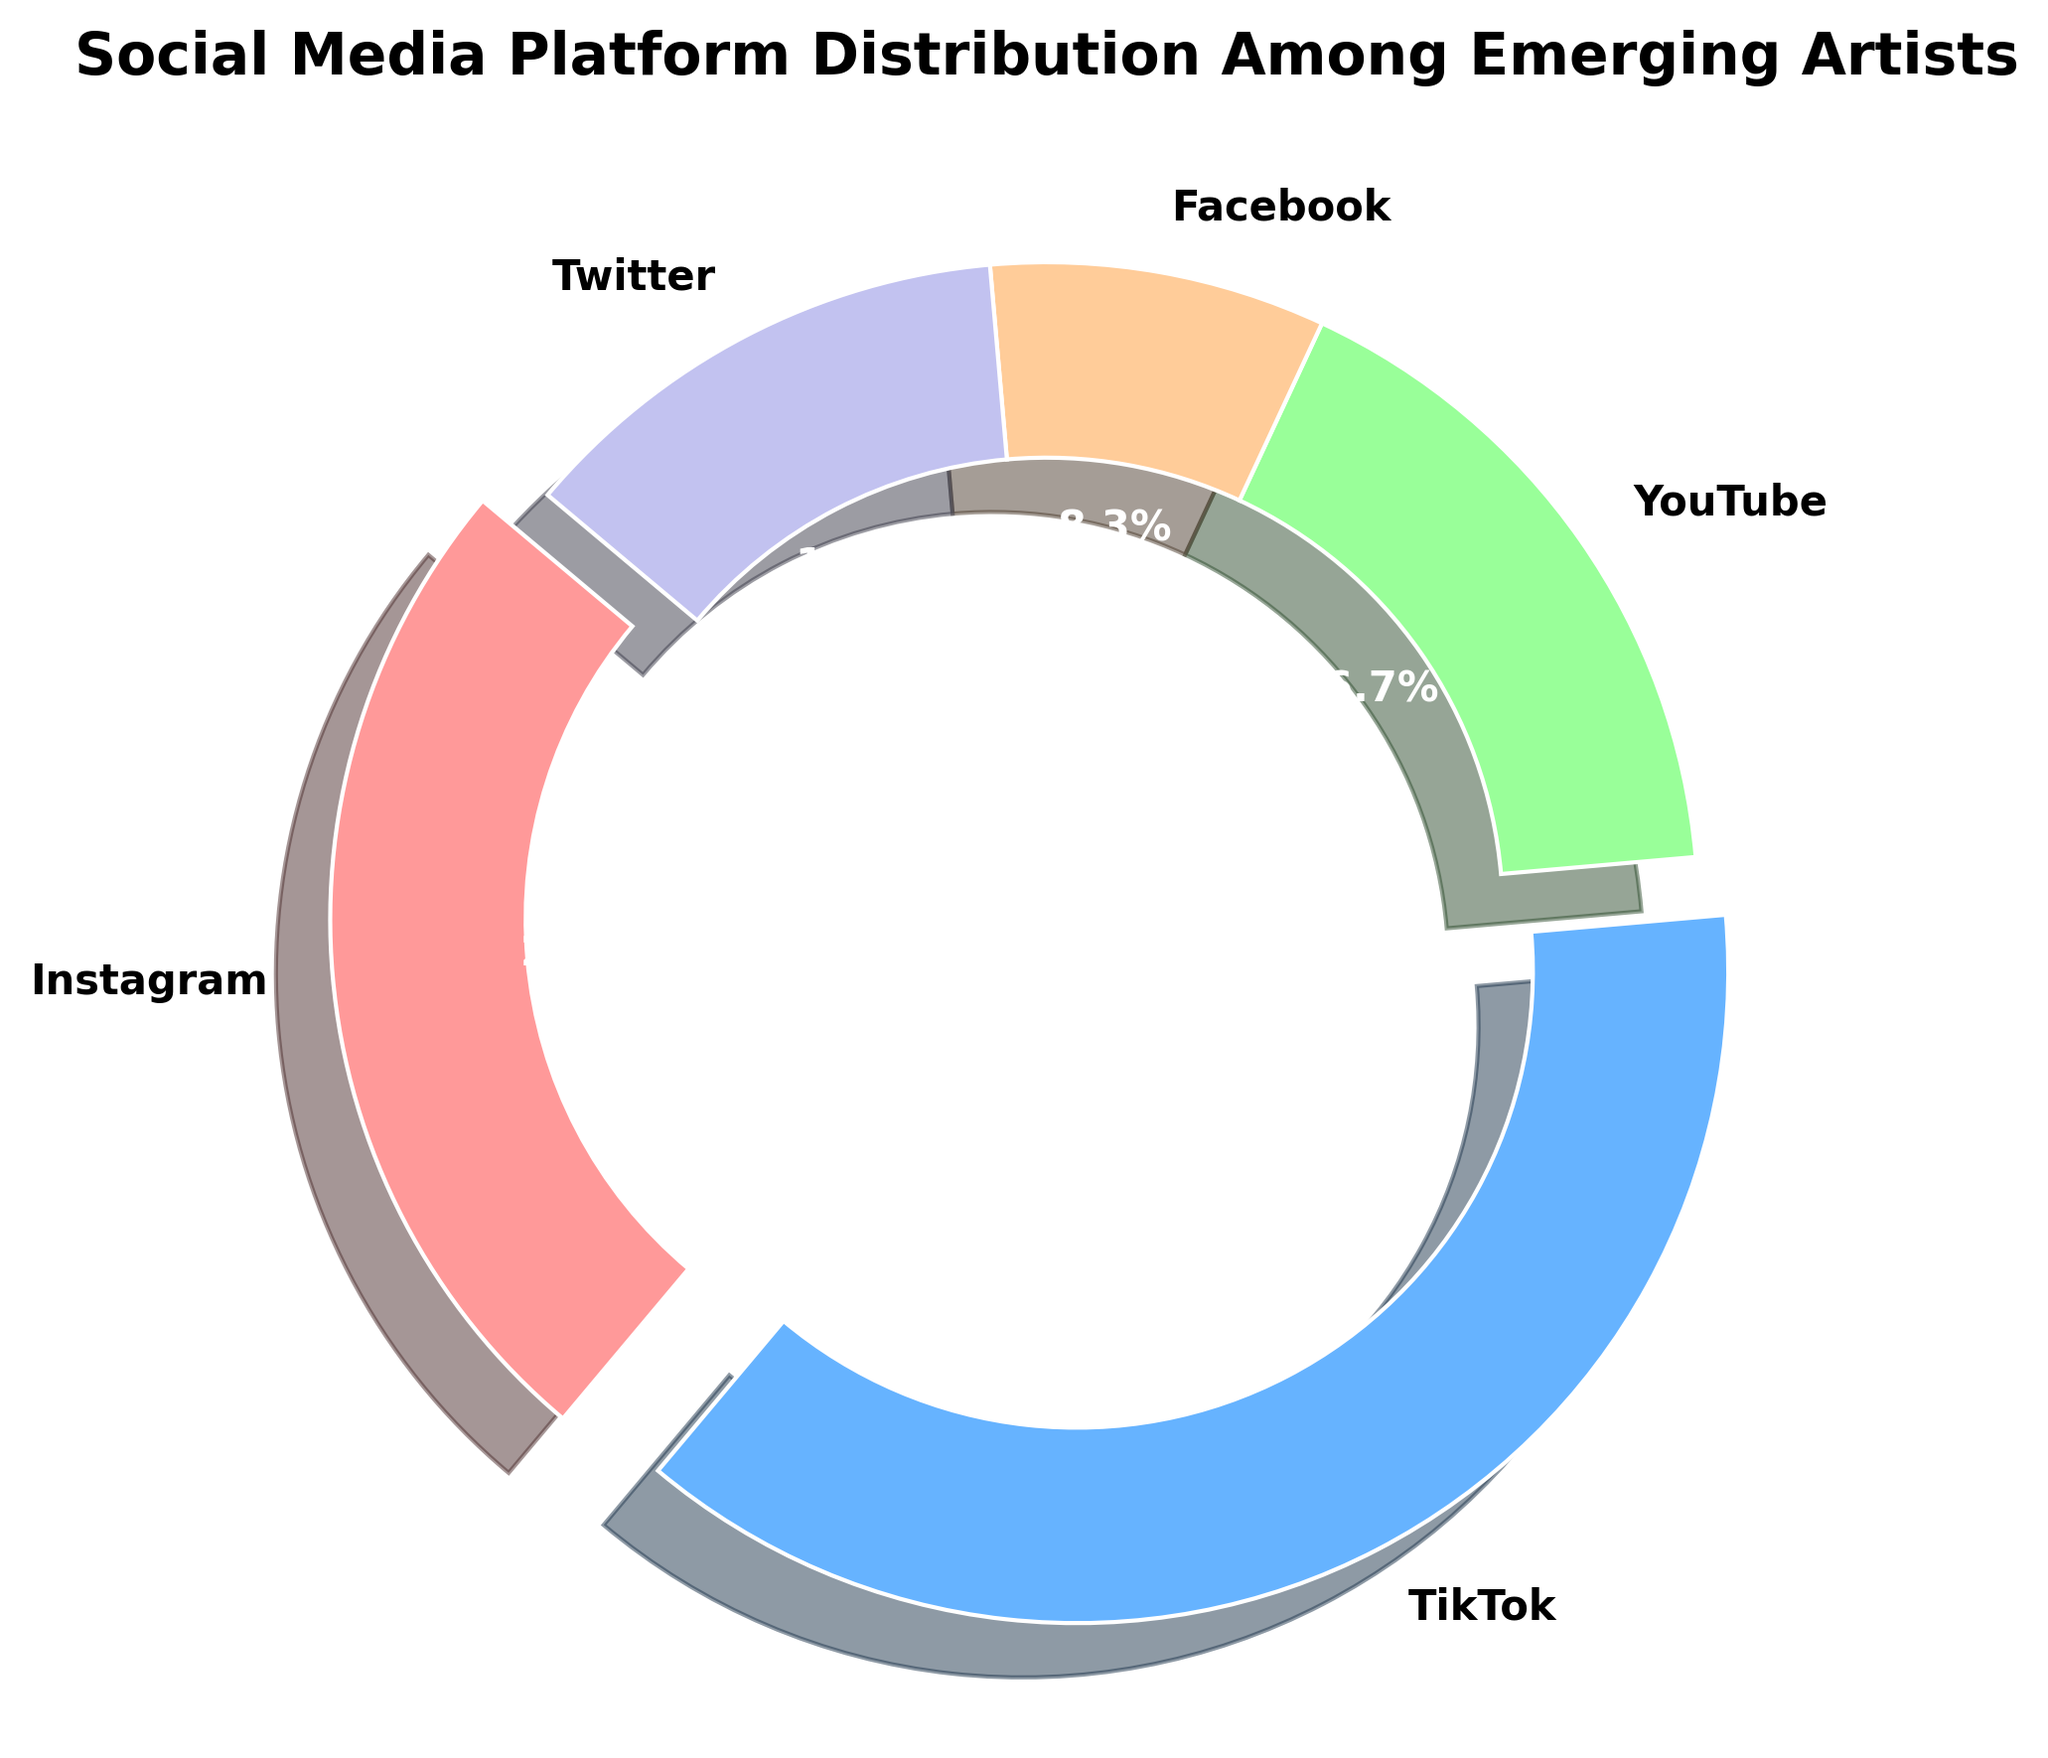Which platform has the highest percentage of emerging artists? The pie chart segments with labels indicate the percentage distribution. The segment labeled "TikTok" has the highest percentage which is 45.9%.
Answer: TikTok Which platform has the lowest percentage of emerging artists? The pie chart segments with labels indicate the percentage distribution. The segment labeled "Facebook" has the lowest percentage which is 10.2%.
Answer: Facebook What is the combined percentage of emerging artists using Twitter and YouTube? The pie chart shows Twitter with 15.3% and YouTube with 20.4%. Adding these, 15.3% + 20.4% = 35.7%.
Answer: 35.7% How much more popular is TikTok compared to Instagram? The chart indicates TikTok with 45.9% and Instagram with 30.6%. To find the difference, 45.9% - 30.6% = 15.3%.
Answer: 15.3% What is the difference in the number of artists between the platform with the most and the platform with the least artists? TikTok is the most with 450 artists, and Facebook the least with 100 artists. The difference is 450 - 100 = 350 artists.
Answer: 350 artists Which platforms are less popular than Instagram? The chart indicates percentages by each platform: TikTok (45.9%), Instagram (30.6%), YouTube (20.4%), Twitter (15.3%), and Facebook (10.2%). Platforms less popular than Instagram are YouTube, Twitter, and Facebook.
Answer: YouTube, Twitter, Facebook What percentage of artists use platforms other than TikTok? TikTok has 45.9%, so the percentage for other platforms is 100% - 45.9% = 54.1%.
Answer: 54.1% If you combine Instagram and Facebook, do they surpass TikTok in percentage? Instagram has 30.6% and Facebook has 10.2%. Combined, 30.6% + 10.2% = 40.8%, which is less than TikTok's 45.9%.
Answer: No Which platform's segment is depicted in green? The color's distribution in the segments indicates that the segment in green represents the YouTube platform.
Answer: YouTube 